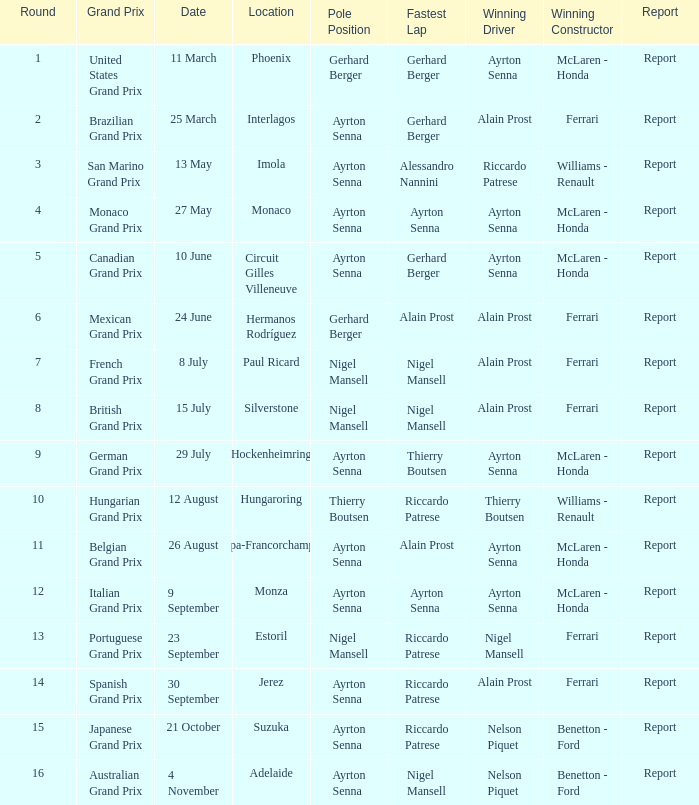When riccardo patrese emerged as the winning driver, who was the constructor? Williams - Renault. 